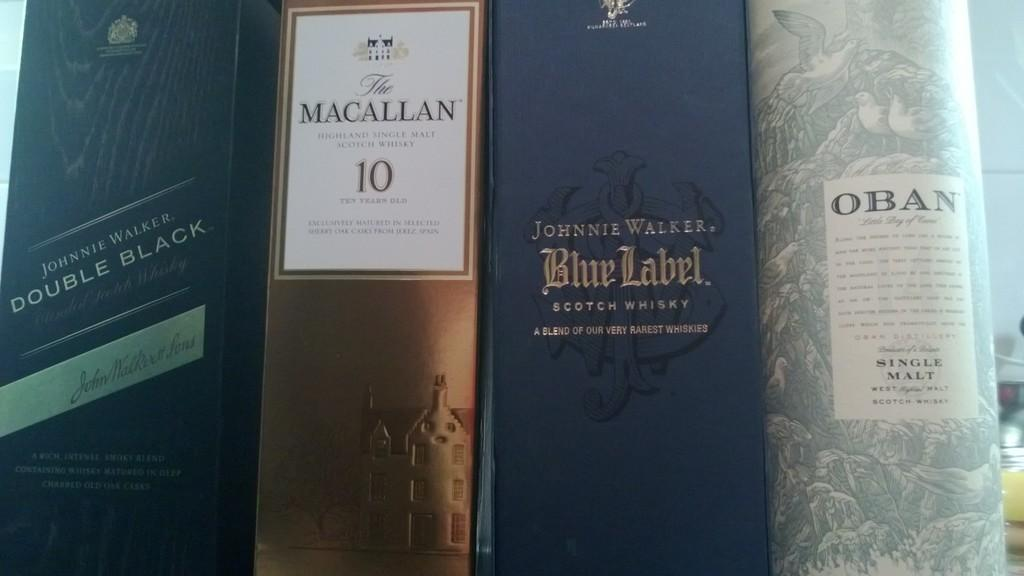Provide a one-sentence caption for the provided image. A collection of four boxed whiskeys include Macallan 10 and Johnnie Walker Blue. 